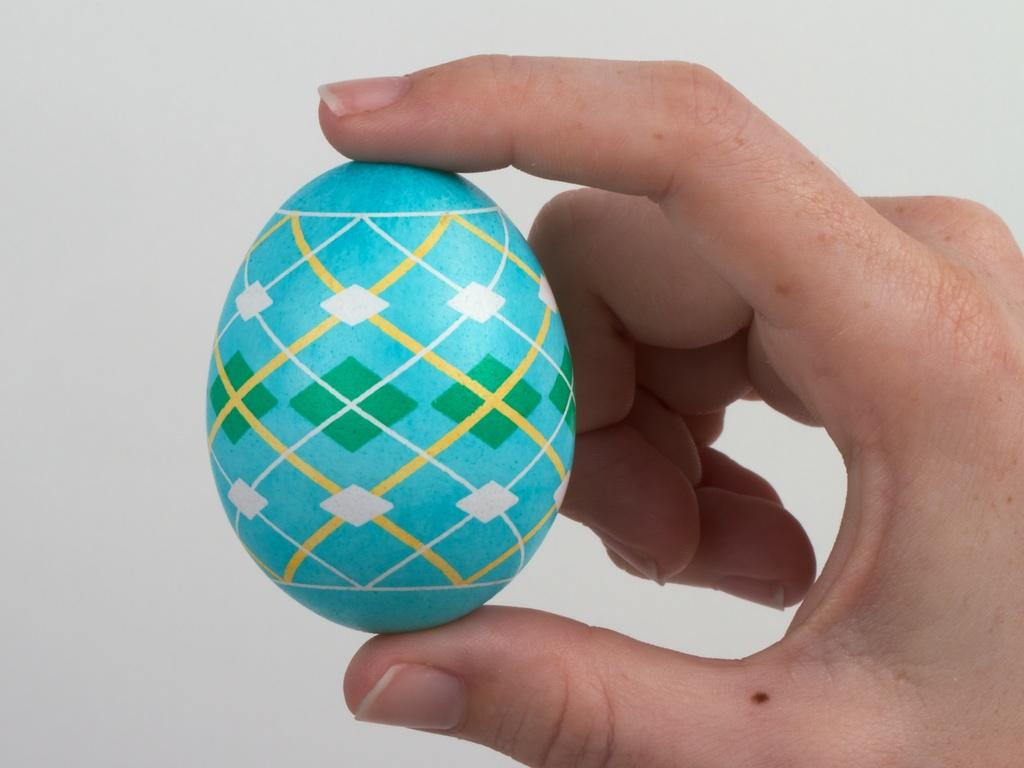What is being held in someone's hand in the image? Unfortunately, the specific object being held cannot be determined from the given facts. What can be said about the background of the image? The background of the image is white. What type of lamp is being offered in the image? There is no lamp present in the image. What wish is being granted in the image? There is no indication of a wish being granted in the image. 